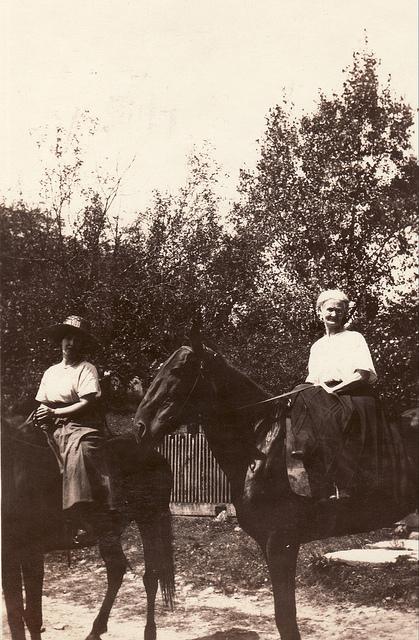Are these horses for recreational or professional use?
Give a very brief answer. Recreational. Is the photo colored?
Concise answer only. No. Is this an old picture?
Write a very short answer. Yes. Are they riding side saddle?
Short answer required. Yes. 